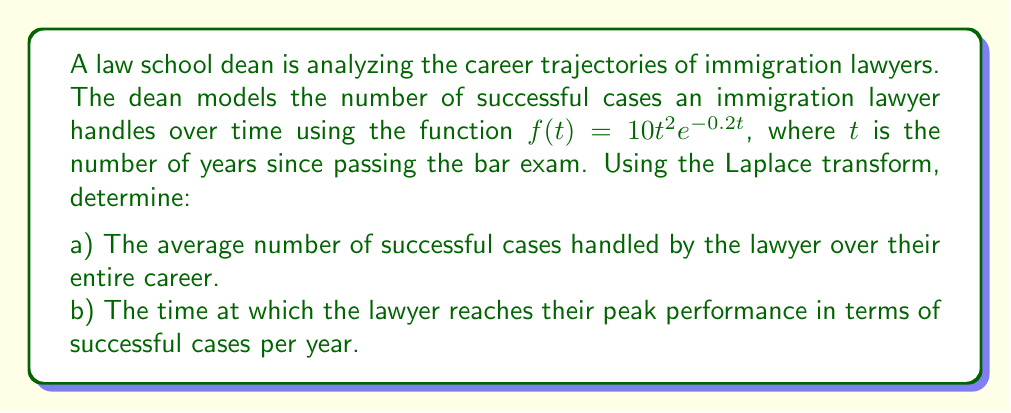Help me with this question. Let's approach this problem step by step using Laplace transforms:

a) To find the average number of successful cases over the entire career:

1) First, we need to calculate the total number of successful cases over the entire career. This is given by the integral of $f(t)$ from 0 to infinity:

   $$\int_0^\infty f(t) dt = \int_0^\infty 10t^2e^{-0.2t} dt$$

2) This integral is difficult to evaluate directly, but it can be easily solved using the Laplace transform. Recall that:

   $$\mathcal{L}\{f(t)\} = F(s) = \int_0^\infty e^{-st}f(t) dt$$

3) In our case, we want $\mathcal{L}\{f(t)\}$ evaluated at $s=0$. This gives us the total number of successful cases:

   $$F(0) = \int_0^\infty f(t) dt$$

4) The Laplace transform of $f(t) = 10t^2e^{-0.2t}$ is:

   $$F(s) = \frac{10 \cdot 2!}{(s+0.2)^3} = \frac{20}{(s+0.2)^3}$$

5) Evaluating at $s=0$:

   $$F(0) = \frac{20}{(0+0.2)^3} = \frac{20}{0.008} = 2500$$

6) Therefore, the total number of successful cases over the entire career is 2500.

7) To get the average per year, we need to divide by the average career length. Assuming a 40-year career:

   Average cases per year = 2500 / 40 = 62.5

b) To find the time of peak performance:

1) We need to find the maximum of $f(t) = 10t^2e^{-0.2t}$

2) Take the derivative and set it to zero:

   $$f'(t) = 20te^{-0.2t} - 2t^2e^{-0.2t} = 0$$

3) Factor out common terms:

   $$20te^{-0.2t} - 2t^2e^{-0.2t} = 2te^{-0.2t}(10 - t) = 0$$

4) Solve for t:

   $t = 0$ or $t = 10$

5) The maximum occurs at $t = 10$ years (since $t = 0$ gives a minimum).
Answer: a) The average number of successful cases handled by the lawyer per year over their entire career is approximately 62.5 cases/year.
b) The lawyer reaches their peak performance 10 years after passing the bar exam. 